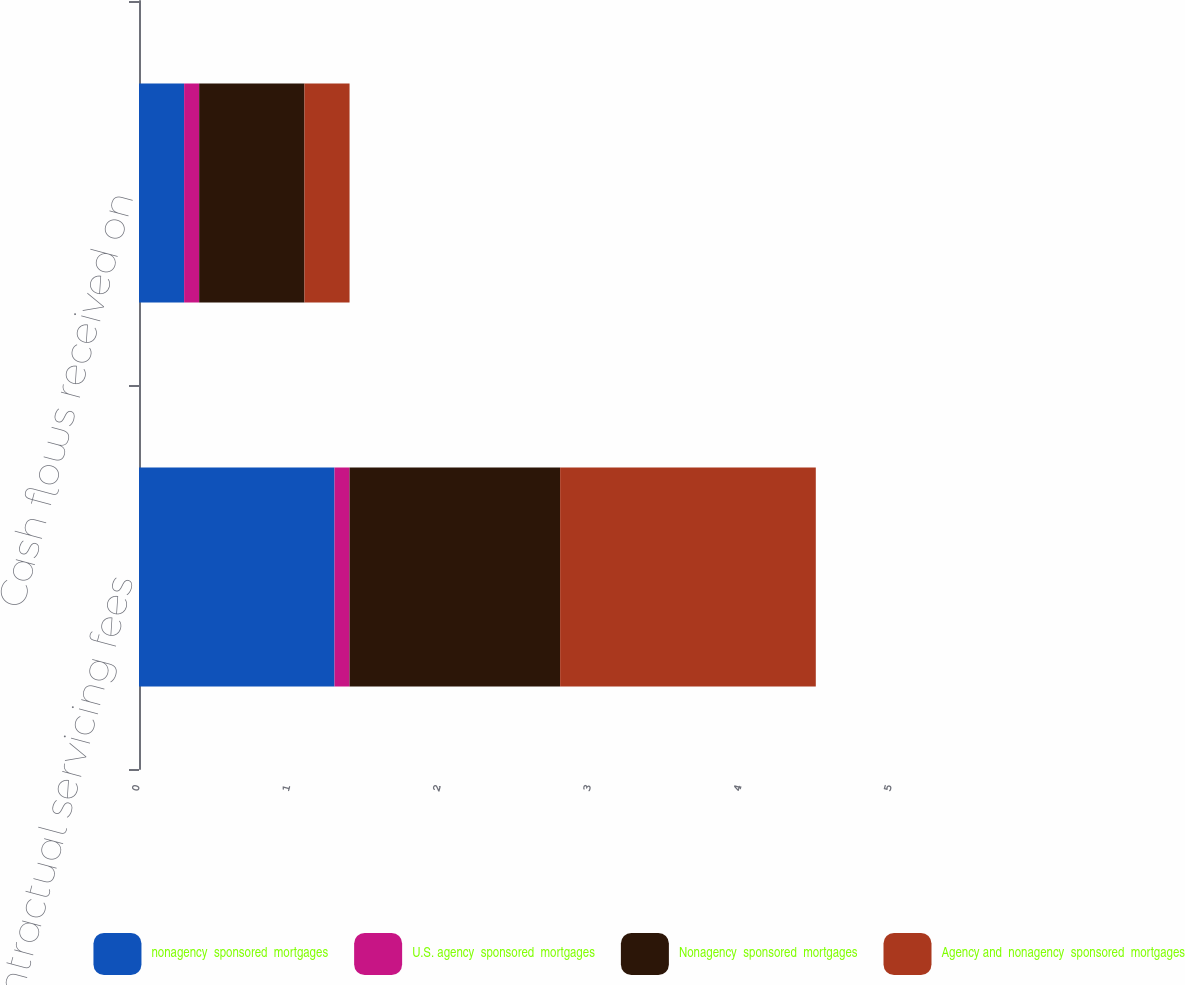Convert chart to OTSL. <chart><loc_0><loc_0><loc_500><loc_500><stacked_bar_chart><ecel><fcel>Contractual servicing fees<fcel>Cash flows received on<nl><fcel>nonagency  sponsored  mortgages<fcel>1.3<fcel>0.3<nl><fcel>U.S. agency  sponsored  mortgages<fcel>0.1<fcel>0.1<nl><fcel>Nonagency  sponsored  mortgages<fcel>1.4<fcel>0.7<nl><fcel>Agency and  nonagency  sponsored  mortgages<fcel>1.7<fcel>0.3<nl></chart> 